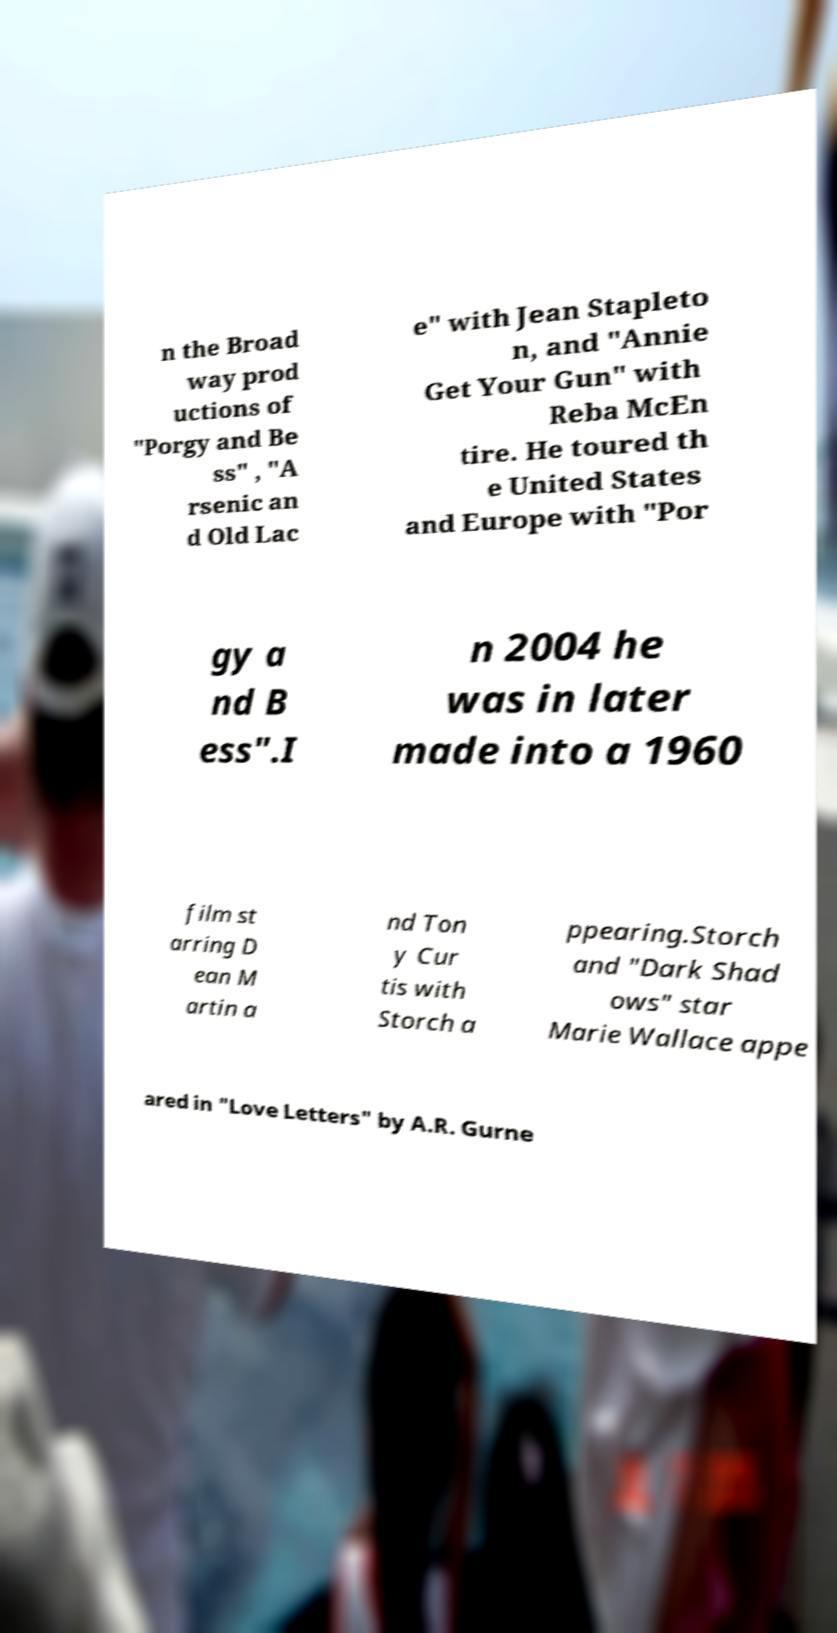Please identify and transcribe the text found in this image. n the Broad way prod uctions of "Porgy and Be ss" , "A rsenic an d Old Lac e" with Jean Stapleto n, and "Annie Get Your Gun" with Reba McEn tire. He toured th e United States and Europe with "Por gy a nd B ess".I n 2004 he was in later made into a 1960 film st arring D ean M artin a nd Ton y Cur tis with Storch a ppearing.Storch and "Dark Shad ows" star Marie Wallace appe ared in "Love Letters" by A.R. Gurne 